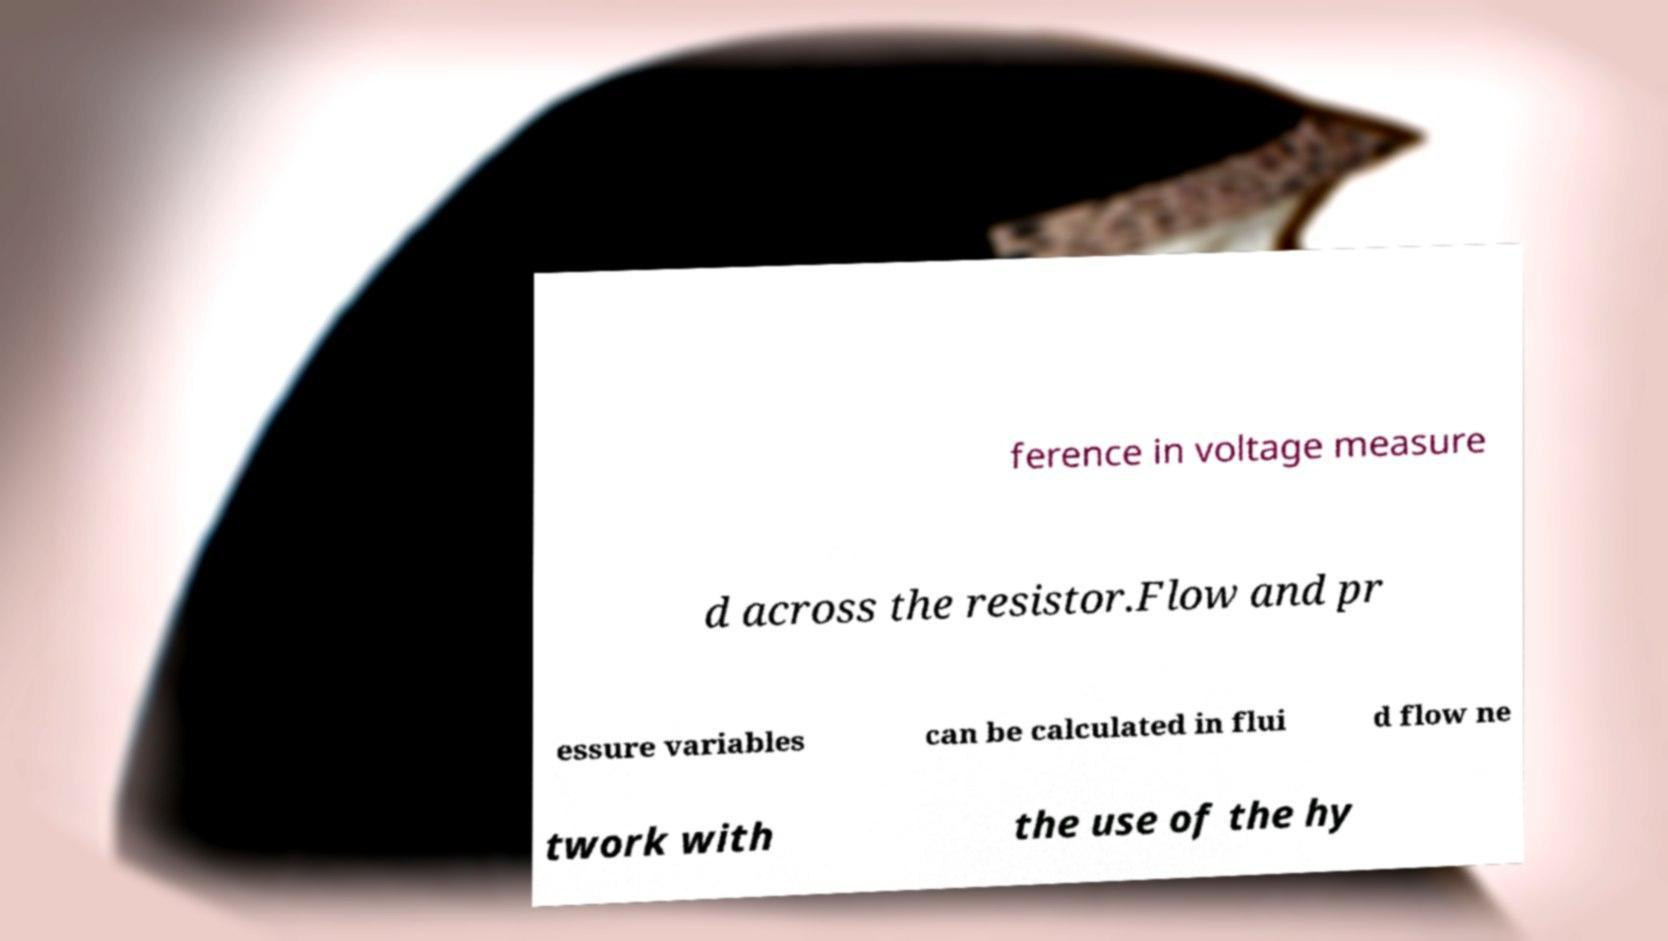Could you assist in decoding the text presented in this image and type it out clearly? ference in voltage measure d across the resistor.Flow and pr essure variables can be calculated in flui d flow ne twork with the use of the hy 